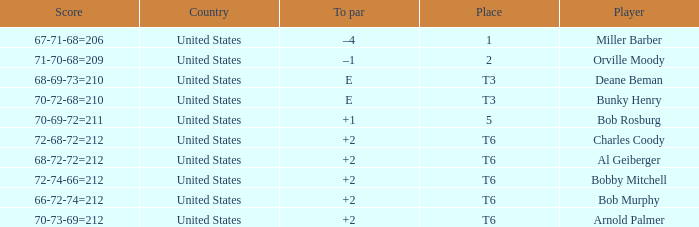What is the to par of player bunky henry? E. 